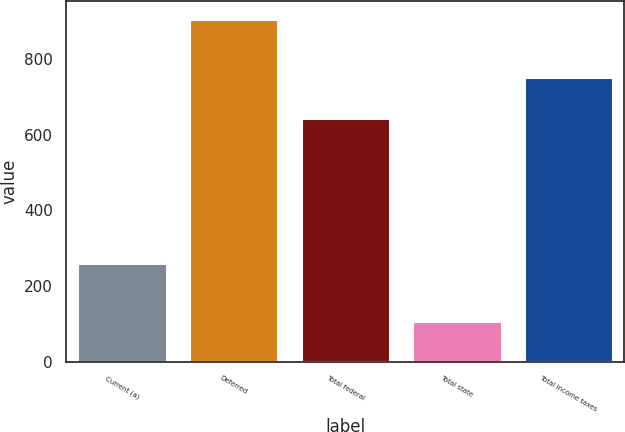<chart> <loc_0><loc_0><loc_500><loc_500><bar_chart><fcel>Current (a)<fcel>Deferred<fcel>Total federal<fcel>Total state<fcel>Total income taxes<nl><fcel>261<fcel>906<fcel>645<fcel>107<fcel>752<nl></chart> 